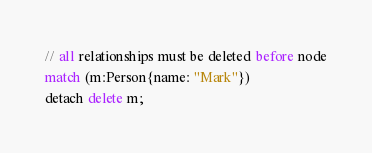<code> <loc_0><loc_0><loc_500><loc_500><_SQL_>// all relationships must be deleted before node
match (m:Person{name: "Mark"})
detach delete m;
</code> 